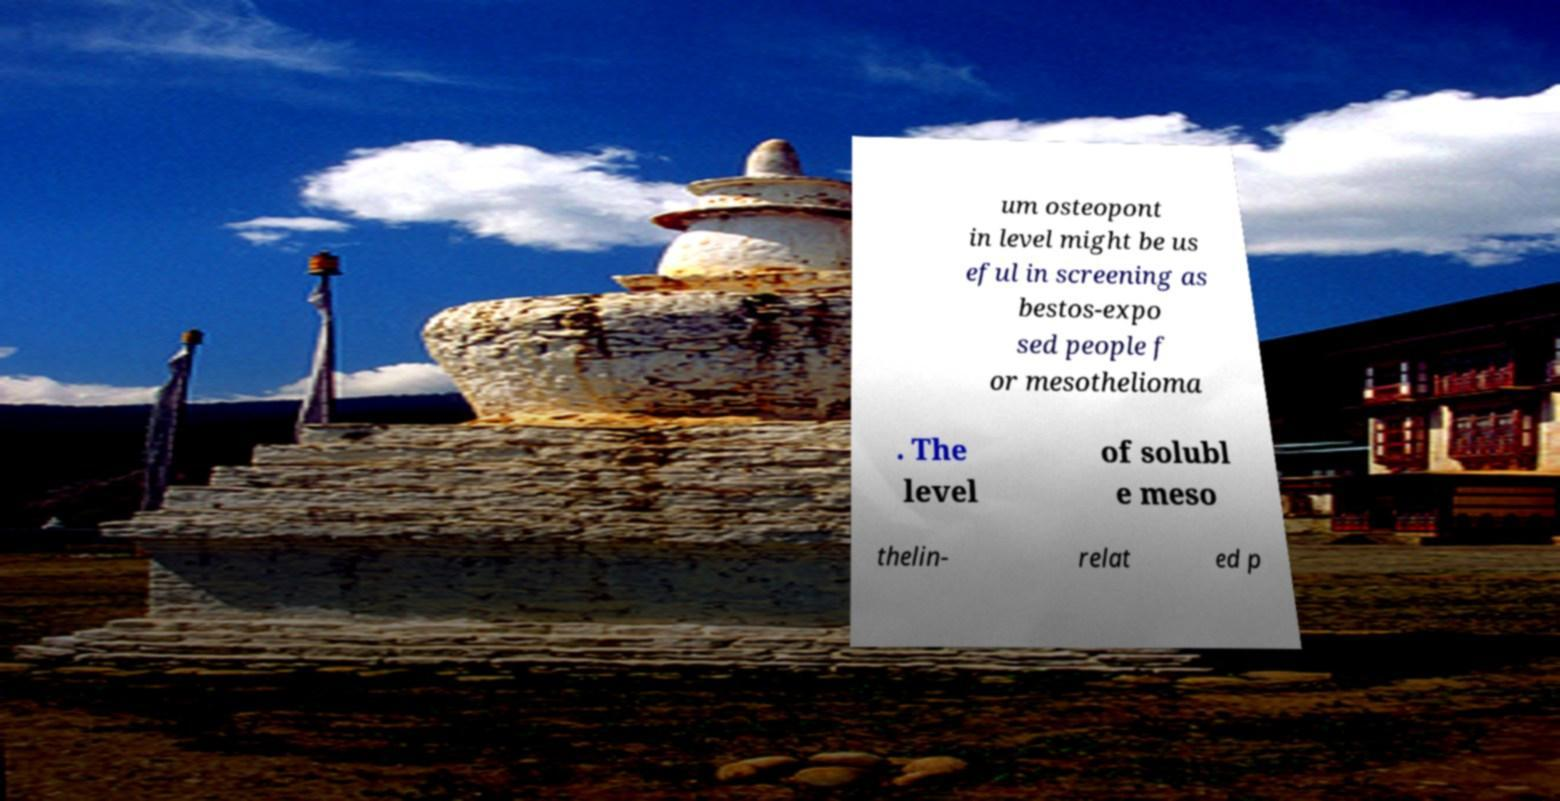I need the written content from this picture converted into text. Can you do that? um osteopont in level might be us eful in screening as bestos-expo sed people f or mesothelioma . The level of solubl e meso thelin- relat ed p 